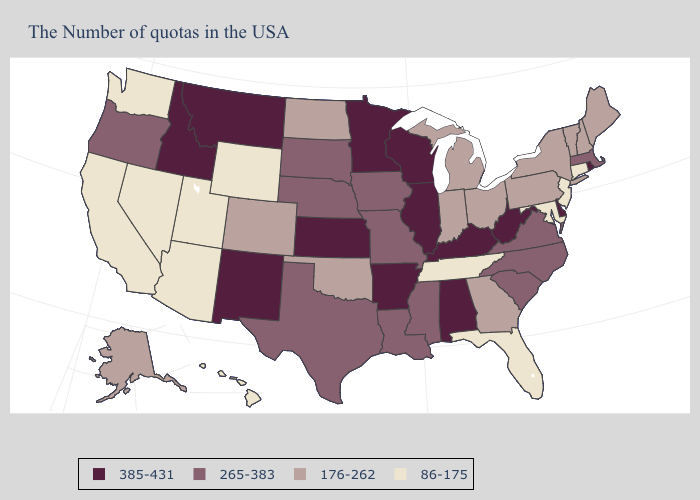What is the highest value in the West ?
Be succinct. 385-431. Name the states that have a value in the range 265-383?
Short answer required. Massachusetts, Virginia, North Carolina, South Carolina, Mississippi, Louisiana, Missouri, Iowa, Nebraska, Texas, South Dakota, Oregon. Among the states that border Illinois , which have the highest value?
Give a very brief answer. Kentucky, Wisconsin. Name the states that have a value in the range 265-383?
Quick response, please. Massachusetts, Virginia, North Carolina, South Carolina, Mississippi, Louisiana, Missouri, Iowa, Nebraska, Texas, South Dakota, Oregon. Name the states that have a value in the range 176-262?
Quick response, please. Maine, New Hampshire, Vermont, New York, Pennsylvania, Ohio, Georgia, Michigan, Indiana, Oklahoma, North Dakota, Colorado, Alaska. What is the value of Nevada?
Answer briefly. 86-175. What is the value of Alaska?
Write a very short answer. 176-262. What is the value of New Hampshire?
Concise answer only. 176-262. What is the value of South Dakota?
Write a very short answer. 265-383. What is the lowest value in the Northeast?
Quick response, please. 86-175. What is the lowest value in the USA?
Give a very brief answer. 86-175. Which states have the lowest value in the USA?
Give a very brief answer. Connecticut, New Jersey, Maryland, Florida, Tennessee, Wyoming, Utah, Arizona, Nevada, California, Washington, Hawaii. Among the states that border Indiana , which have the lowest value?
Be succinct. Ohio, Michigan. What is the value of South Dakota?
Be succinct. 265-383. How many symbols are there in the legend?
Short answer required. 4. 